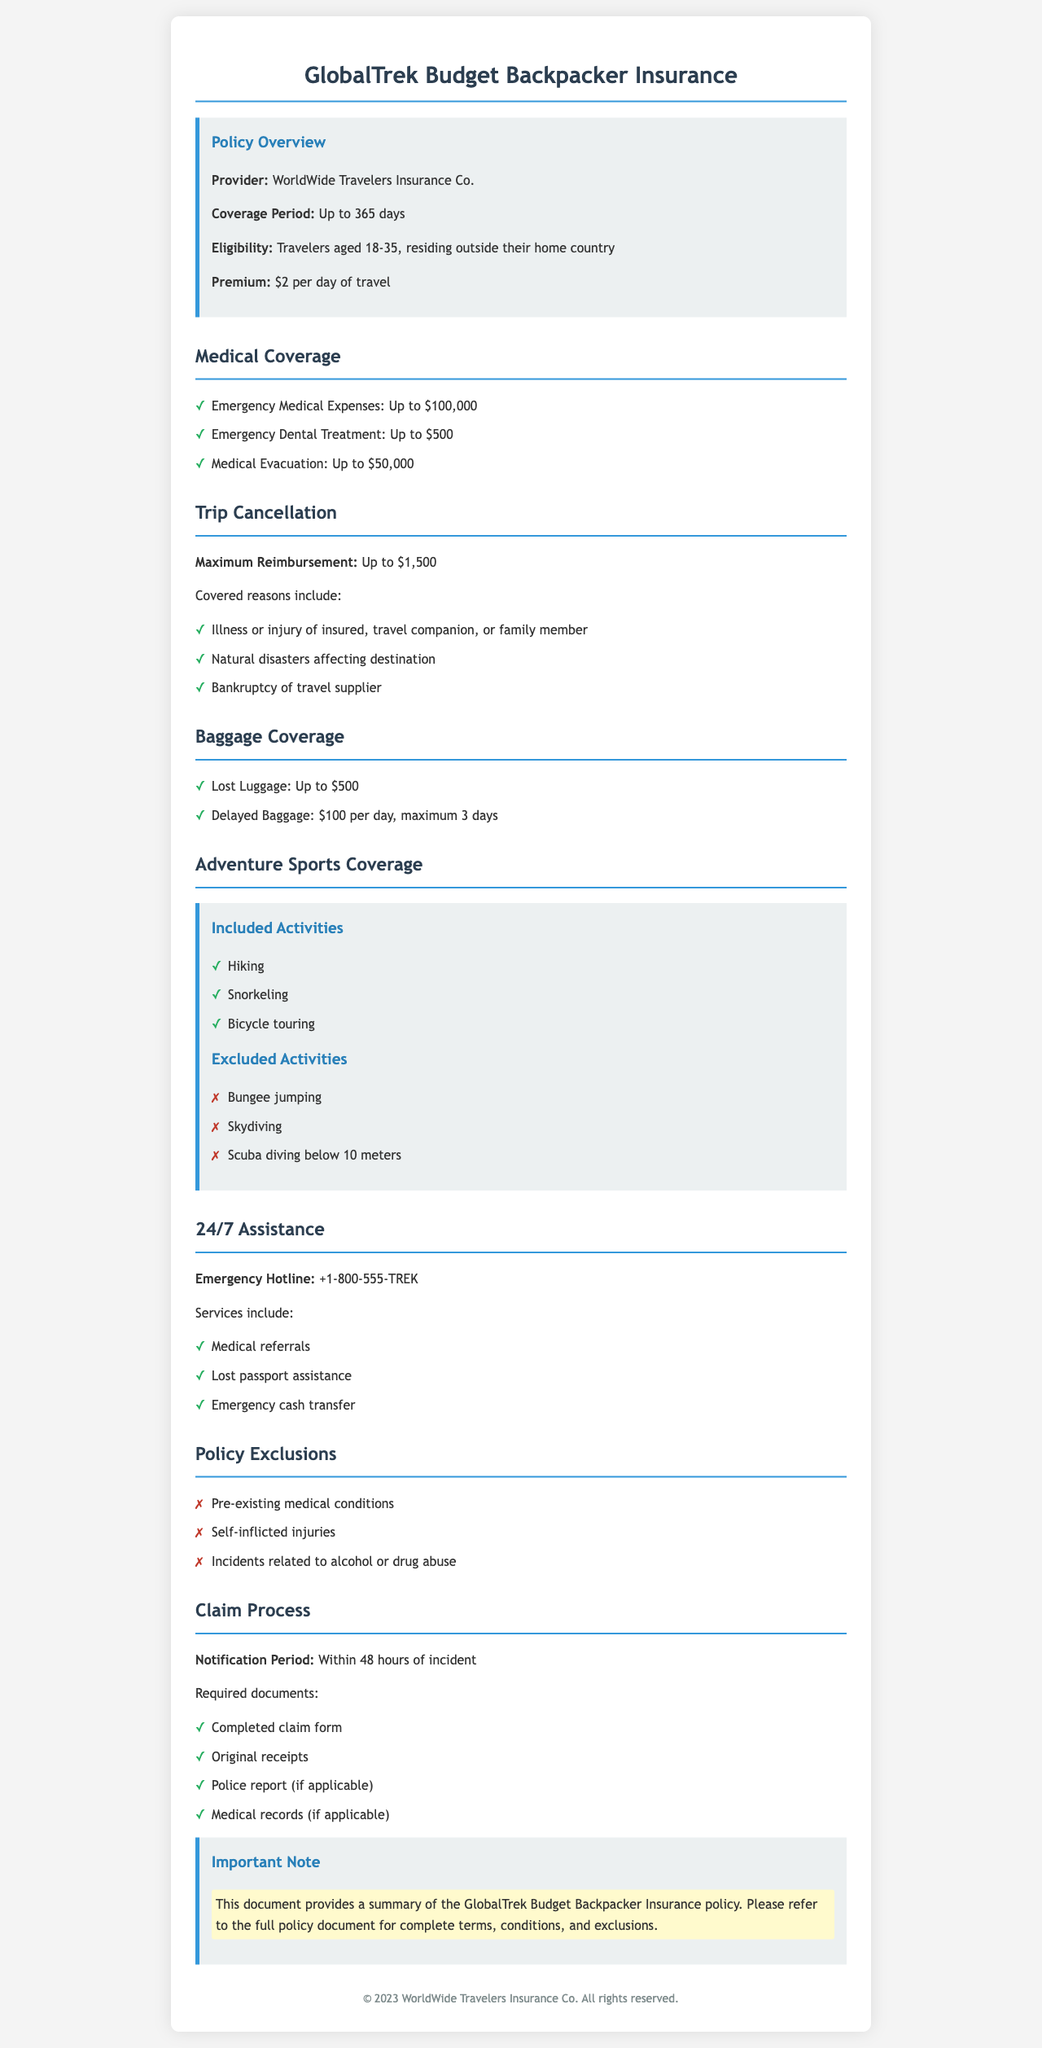What is the maximum reimbursement for trip cancellation? The maximum reimbursement amount listed for trip cancellation in the document is $1,500.
Answer: $1,500 What is included in emergency medical coverage? The document specifies that emergency medical expenses coverage includes up to $100,000, plus emergency dental treatment and medical evacuation.
Answer: Up to $100,000 How much is the daily premium for this insurance policy? The document states that the premium for the insurance policy is $2 per day of travel.
Answer: $2 What is the coverage amount for lost luggage? The policy covers lost luggage up to $500 as indicated in the baggage coverage section.
Answer: Up to $500 What should be submitted along with a claim? Required documents for a claim include: completed claim form, original receipts, police report, and medical records if applicable.
Answer: Completed claim form, original receipts, police report, and medical records Which age range is eligible for the insurance? The policy outlines that eligibility is for travelers aged 18-35, residing outside their home country.
Answer: 18-35 What is the maximum reimbursement for delayed baggage? The maximum reimbursement for delayed baggage is $100 per day for a maximum of 3 days.
Answer: $100 per day, maximum 3 days What activities are excluded from adventure sports coverage? Excluded activities include bungee jumping, skydiving, and scuba diving below 10 meters.
Answer: Bungee jumping, skydiving, and scuba diving below 10 meters What is the emergency hotline number? The emergency hotline number provided in the document is +1-800-555-TREK.
Answer: +1-800-555-TREK 